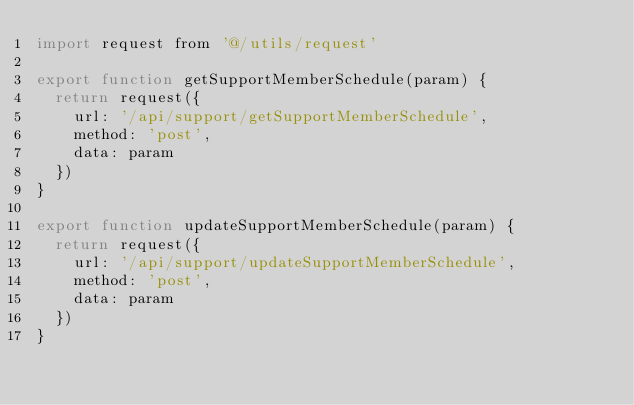<code> <loc_0><loc_0><loc_500><loc_500><_JavaScript_>import request from '@/utils/request'

export function getSupportMemberSchedule(param) {
  return request({
    url: '/api/support/getSupportMemberSchedule',
    method: 'post',
    data: param
  })
}

export function updateSupportMemberSchedule(param) {
  return request({
    url: '/api/support/updateSupportMemberSchedule',
    method: 'post',
    data: param
  })
}
</code> 